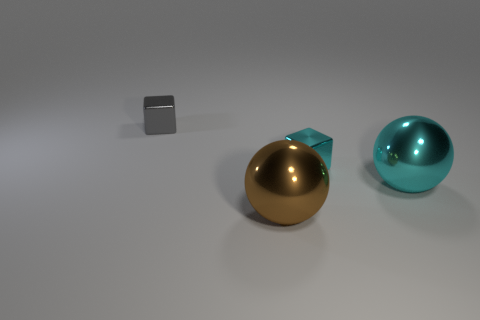Can you describe the positioning of the objects in this image? Certainly! You're looking at a composition of three objects on a flat surface with a soft shadow beneath them, suggesting diffused lighting from above. On the left is a small metallic cube with a matte finish, placed farthest from the camera. In the center, there's a gold reflective sphere, taking the central visual focus due to its shine and color. To the right is a larger, blue-green reflective sphere, closest to the camera, with a shiny surface that captures light and reflects the environment.  What does the lighting in this image suggest about the setting? The lighting in this image is soft and diffused, indicating the possibility of an overcast sky or a studio setting with a softbox light source intended to minimize harsh shadows. This kind of lighting is typically used in photography to evenly illuminate objects, enhancing the objects’ colors and textures with minimal distraction from the shadows. 